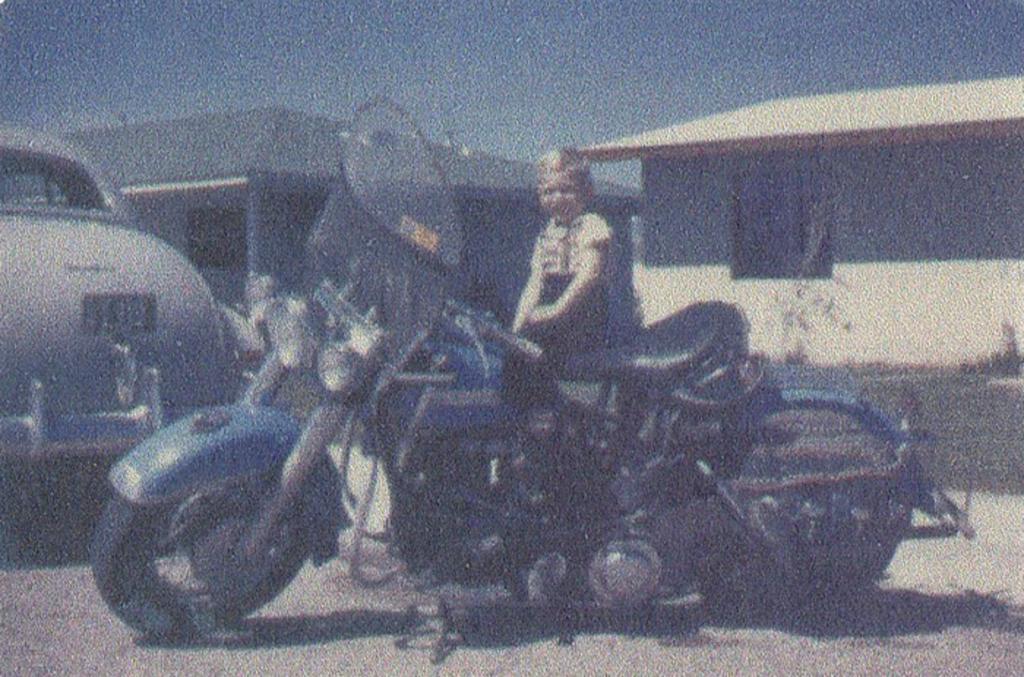Describe this image in one or two sentences. In this image there is a motorbike in the middle on which there is a kid. On the left side there is a car beside the motorbike. In the background there are two houses. At the top there is sky. 